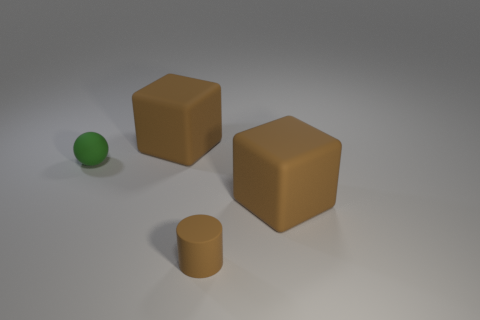Are the objects arranged in a pattern? The objects do not appear to follow a specific pattern. They are placed at varying distances from each other, with no apparent sequence or repetitious arrangement. 